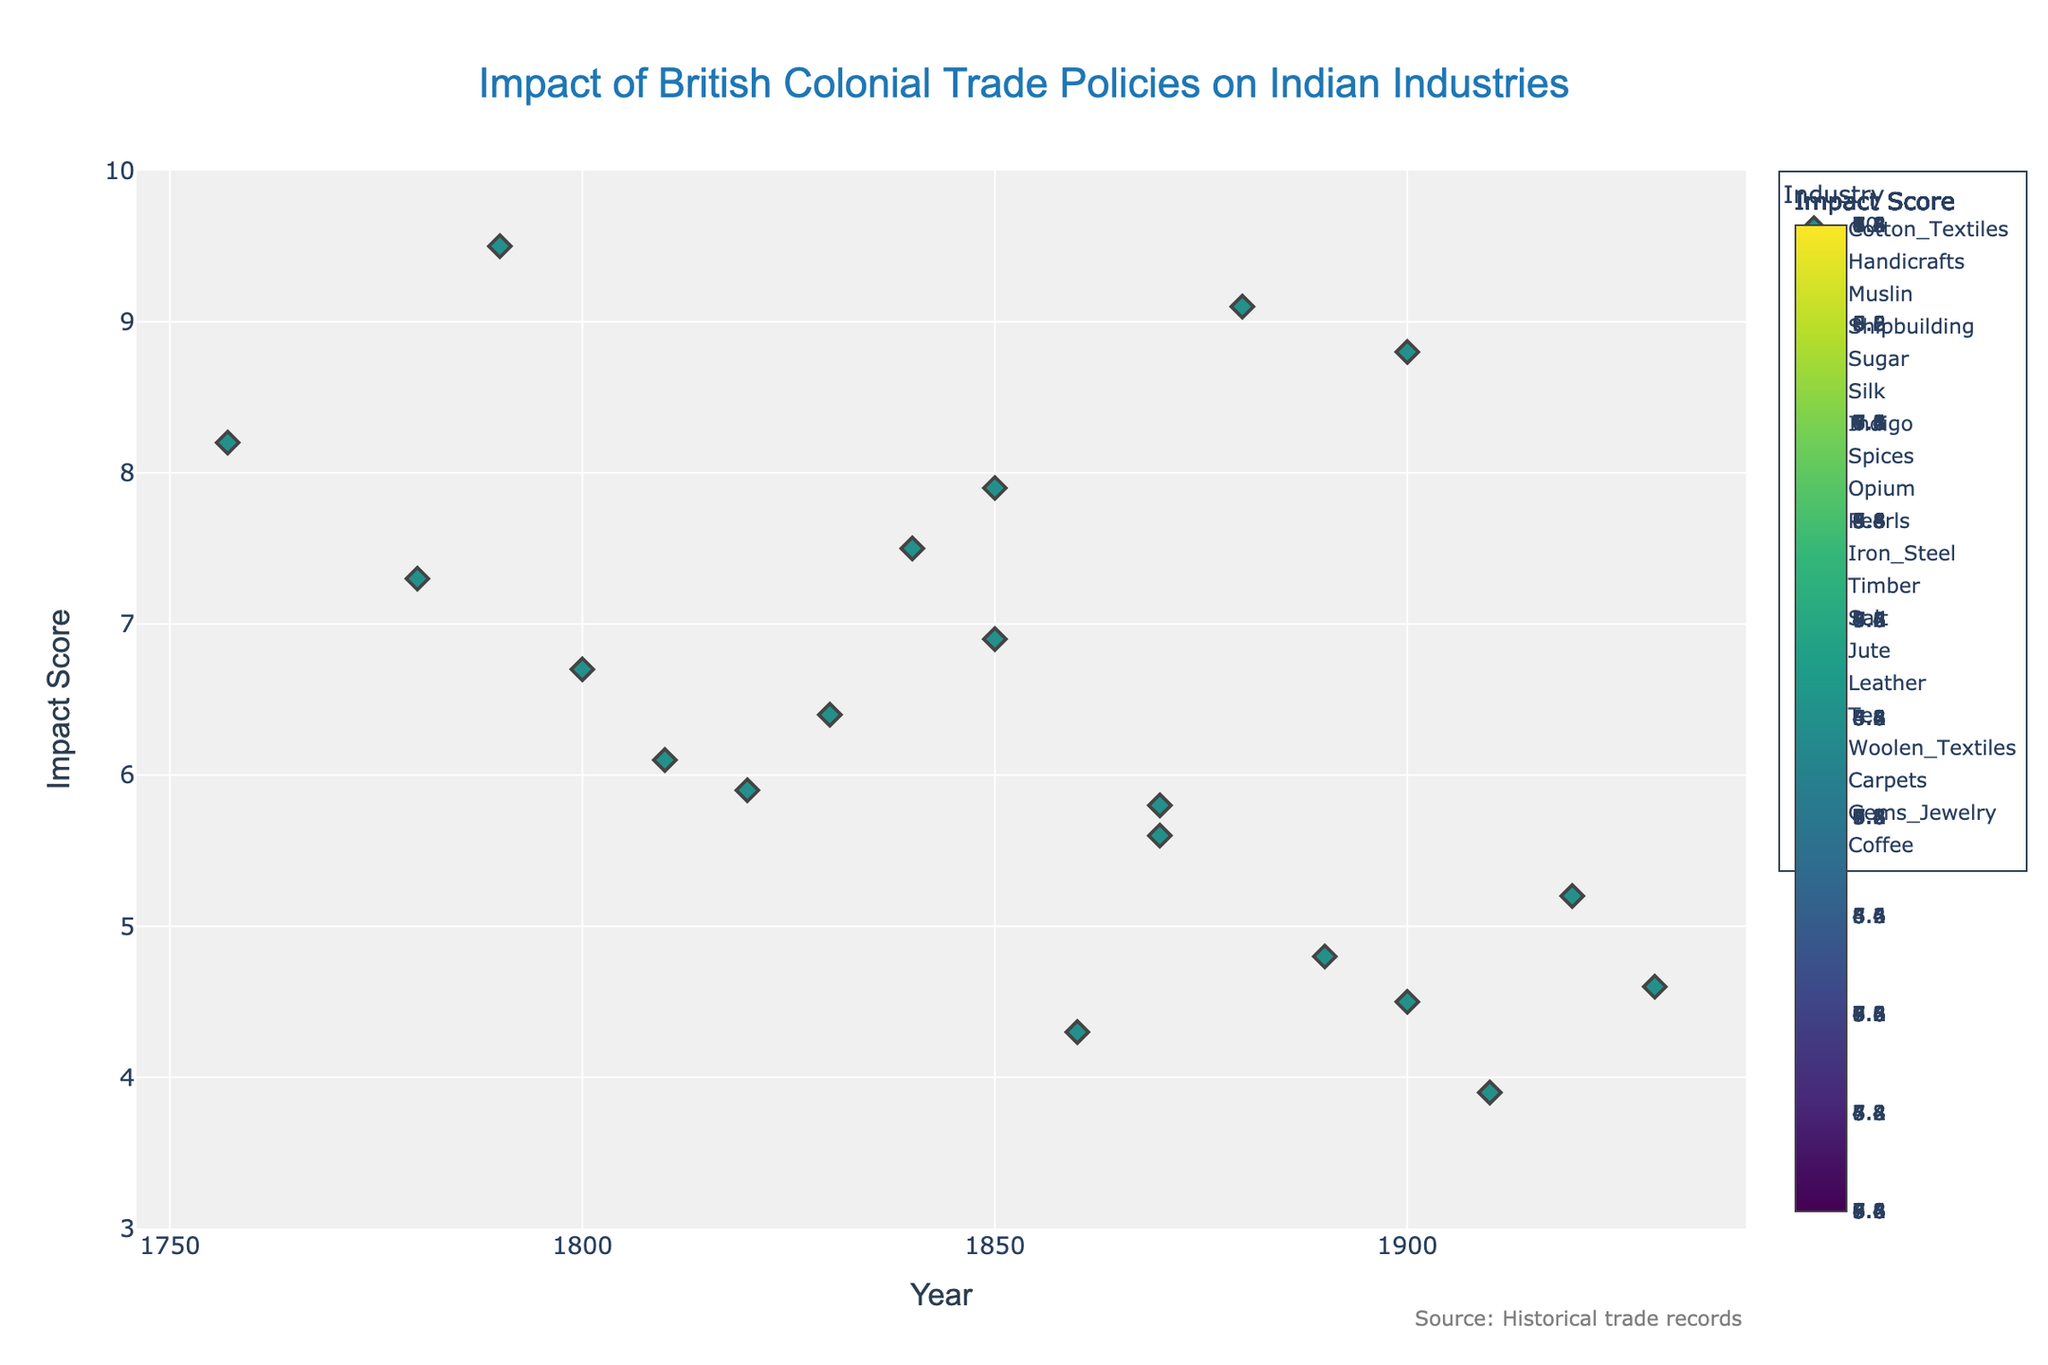What is the title of the plot? The title of the plot is shown at the top and reads "Impact of British Colonial Trade Policies on Indian Industries".
Answer: Impact of British Colonial Trade Policies on Indian Industries Which industry has the highest impact score? To find the highest impact score, we look for the point on the y-axis that is the highest, which corresponds to the industry "Muslin" with an impact score of 9.5
Answer: Muslin How many industries have an impact score of 7.5 or higher? By examining the y-axis and counting the markers at or above 7.5, we find industries: Cotton_Textiles, Spices, Jute, Tea, Indigo, Muslin, Opium, and Handicrafts, totaling 8 industries.
Answer: 8 Which regions have industries impacted in the year 1850? Locate the year 1850 on the x-axis and check the markers. The regions impacted are Madhya_Pradesh (Opium) and Tamil_Nadu (Pearls).
Answer: Madhya_Pradesh, Tamil_Nadu What is the average impact score of industries impacted after the year 1900? Identify all points after 1900, which are "Tea (1900, 8.8)", "Carpets (1910, 3.9)", "Gems_Jewelry (1920, 5.2)", and "Coffee (1930, 4.6)". The average is calculated as (8.8 + 3.9 + 5.2 + 4.6) / 4 = 5.625.
Answer: 5.625 Which industry had an impact in the year 1820 and what is its score? Locate the year 1820 on the x-axis and examine the marker. The industry is "Silk" with an impact score of 5.9.
Answer: Silk, 5.9 Compare the impact scores of the Tea and Jute industries; which one has a higher impact score and by how much? Identify the impact scores for Tea (8.8) and Jute (9.1), then subtract the smaller from the larger: 9.1 - 8.8 = 0.3.
Answer: Jute, 0.3 What is the impact score range in the plot? Identify the minimum and maximum impact scores on the y-axis. The minimum score is for Carpets at 3.9, and the maximum is for Muslin at 9.5. The range is 9.5 - 3.9 = 5.6.
Answer: 5.6 Which industry in Bengal was impacted first according to the plot, and what was the impact score? Examine the x-axis and the data points for Bengal. The earliest impact in Bengal was for Cotton_Textiles in 1757 with an impact score of 8.2.
Answer: Cotton_Textiles, 8.2 